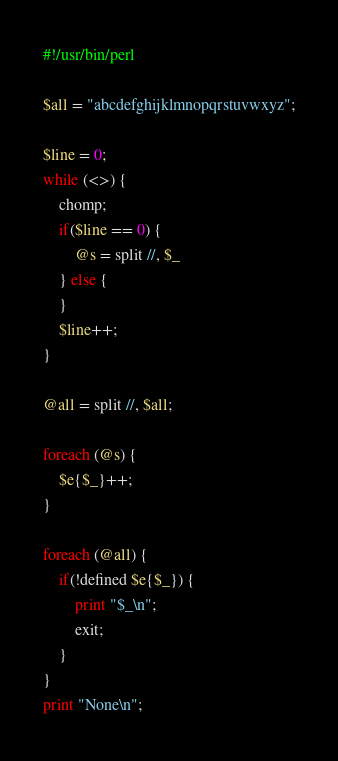Convert code to text. <code><loc_0><loc_0><loc_500><loc_500><_Perl_>#!/usr/bin/perl

$all = "abcdefghijklmnopqrstuvwxyz";

$line = 0;
while (<>) {
    chomp;
    if($line == 0) {
        @s = split //, $_
    } else {
    }
    $line++;
}

@all = split //, $all;

foreach (@s) {
    $e{$_}++;
}

foreach (@all) {
    if(!defined $e{$_}) {
        print "$_\n";
        exit;
    }
}
print "None\n";
</code> 